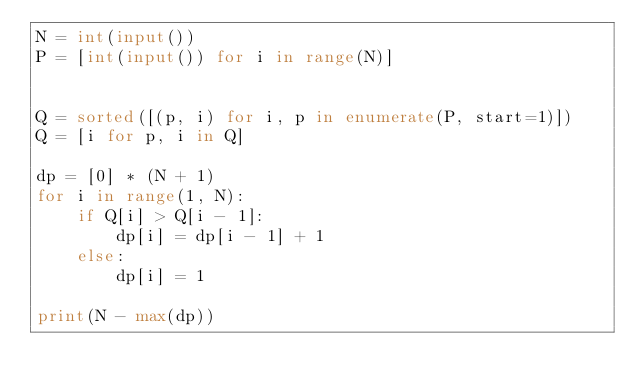<code> <loc_0><loc_0><loc_500><loc_500><_Python_>N = int(input())
P = [int(input()) for i in range(N)]


Q = sorted([(p, i) for i, p in enumerate(P, start=1)])
Q = [i for p, i in Q]

dp = [0] * (N + 1)
for i in range(1, N):
    if Q[i] > Q[i - 1]:
        dp[i] = dp[i - 1] + 1
    else:
        dp[i] = 1

print(N - max(dp))
</code> 